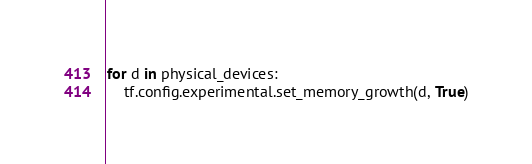<code> <loc_0><loc_0><loc_500><loc_500><_Python_>for d in physical_devices:
    tf.config.experimental.set_memory_growth(d, True)
</code> 